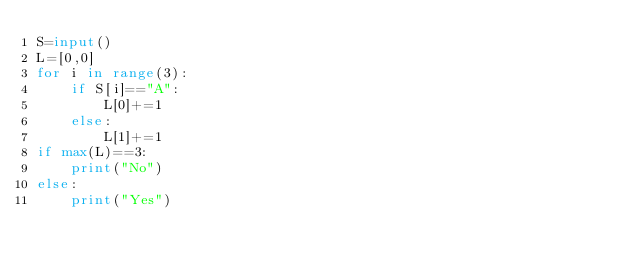<code> <loc_0><loc_0><loc_500><loc_500><_Python_>S=input()
L=[0,0]
for i in range(3):
    if S[i]=="A":
        L[0]+=1
    else:
        L[1]+=1
if max(L)==3:
    print("No")
else:
    print("Yes")</code> 